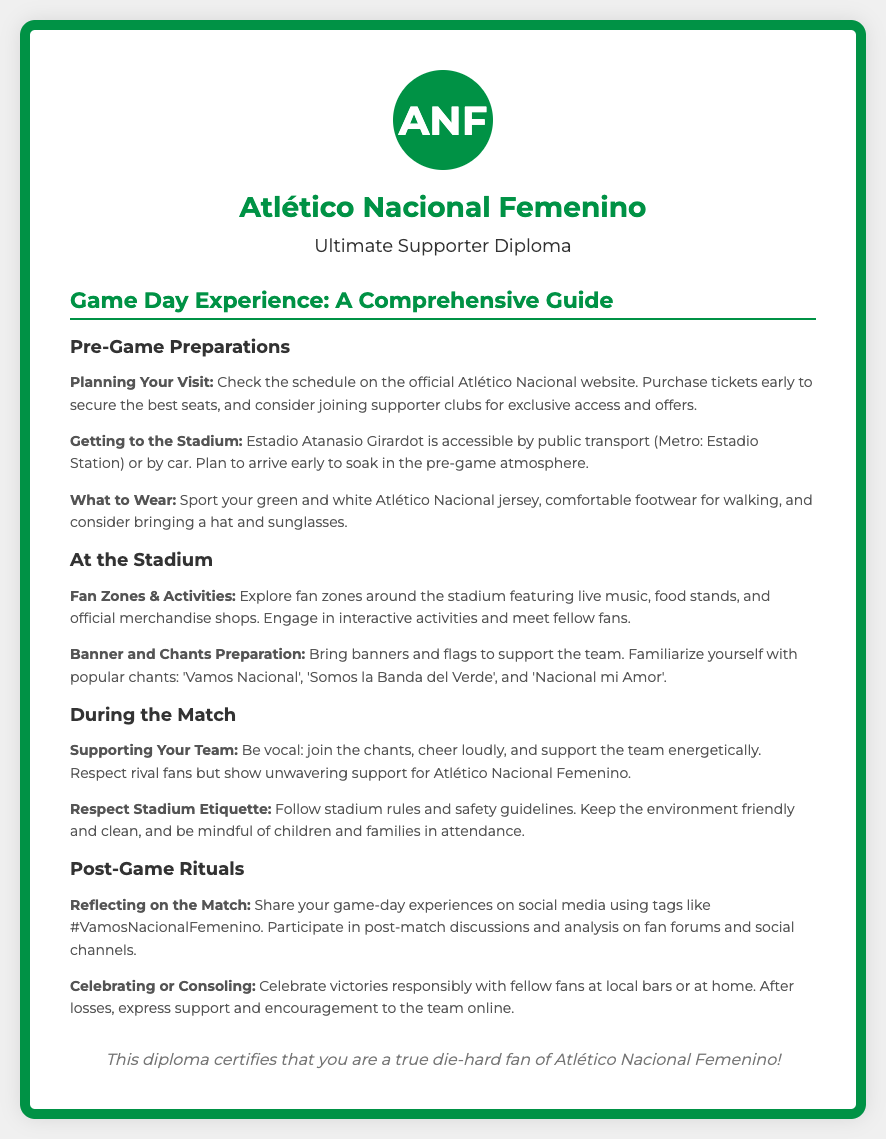What is the title of the diploma? The title of the diploma is found at the top of the document, which indicates the focus of the content.
Answer: Atlético Nacional Femenino Fan Diploma What is the name of the stadium? The name of the stadium is specified in the document as the location for Atlético Nacional Femenino's matches.
Answer: Estadio Atanasio Girardot What should fans wear to the game? The document mentions specific attire that fans are encouraged to wear while attending the game.
Answer: Green and white Atlético Nacional jersey How can fans engage with each other at the stadium? The document lists activities designed to promote fan interaction before the game.
Answer: Explore fan zones What should fans do to support their team during the match? The document highlights actions fans are encouraged to take while cheering for their team.
Answer: Join the chants What are the hashtags suggested for post-game sharing? The document provides social media tags for fans to use after the game.
Answer: #VamosNacionalFemenino What is one way to celebrate a victory? The document suggests a location where fans can celebrate a win together responsibly.
Answer: Local bars How should fans respect stadium etiquette? The document includes guidelines that fans are encouraged to follow for a positive experience.
Answer: Follow stadium rules What is encouraged during post-match discussions? The document emphasizes what fans can participate in after the game regarding team analysis.
Answer: Post-match discussions 